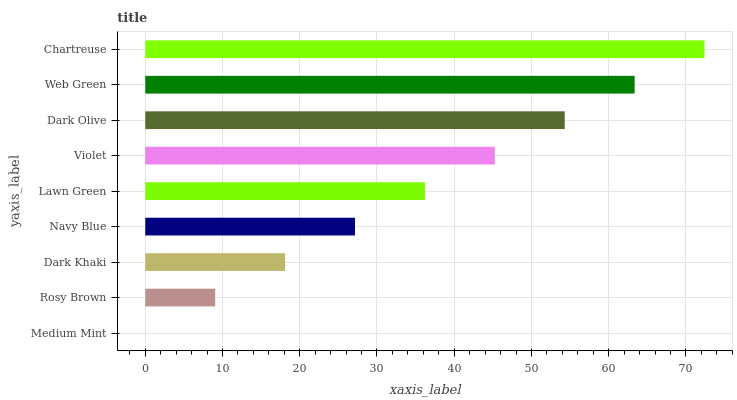Is Medium Mint the minimum?
Answer yes or no. Yes. Is Chartreuse the maximum?
Answer yes or no. Yes. Is Rosy Brown the minimum?
Answer yes or no. No. Is Rosy Brown the maximum?
Answer yes or no. No. Is Rosy Brown greater than Medium Mint?
Answer yes or no. Yes. Is Medium Mint less than Rosy Brown?
Answer yes or no. Yes. Is Medium Mint greater than Rosy Brown?
Answer yes or no. No. Is Rosy Brown less than Medium Mint?
Answer yes or no. No. Is Lawn Green the high median?
Answer yes or no. Yes. Is Lawn Green the low median?
Answer yes or no. Yes. Is Dark Olive the high median?
Answer yes or no. No. Is Dark Olive the low median?
Answer yes or no. No. 